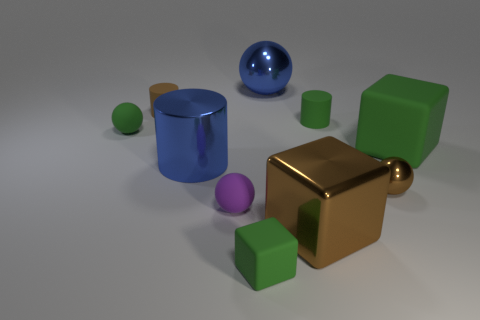There is a brown object that is the same material as the tiny brown ball; what is its shape?
Offer a terse response. Cube. Is there anything else that has the same color as the metallic cylinder?
Offer a very short reply. Yes. There is a tiny green object that is in front of the tiny green sphere behind the big green object; what is its material?
Provide a short and direct response. Rubber. Is there another matte object of the same shape as the purple matte thing?
Provide a succinct answer. Yes. How many other things are there of the same shape as the small purple thing?
Keep it short and to the point. 3. There is a tiny green matte thing that is right of the small brown cylinder and on the left side of the green cylinder; what shape is it?
Offer a very short reply. Cube. There is a green block to the left of the big sphere; what size is it?
Ensure brevity in your answer.  Small. Does the green cylinder have the same size as the blue sphere?
Offer a terse response. No. Is the number of small green rubber cubes that are left of the big metallic block less than the number of tiny green rubber things on the left side of the purple matte ball?
Offer a very short reply. No. How big is the green rubber thing that is right of the big brown cube and in front of the small green sphere?
Keep it short and to the point. Large. 